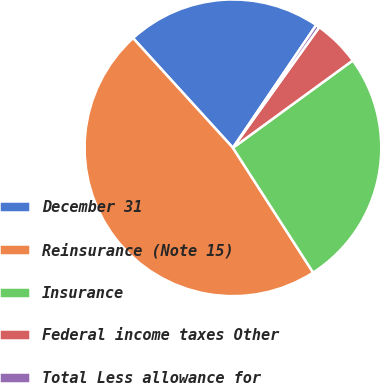Convert chart to OTSL. <chart><loc_0><loc_0><loc_500><loc_500><pie_chart><fcel>December 31<fcel>Reinsurance (Note 15)<fcel>Insurance<fcel>Federal income taxes Other<fcel>Total Less allowance for<nl><fcel>21.24%<fcel>47.34%<fcel>25.93%<fcel>5.09%<fcel>0.4%<nl></chart> 